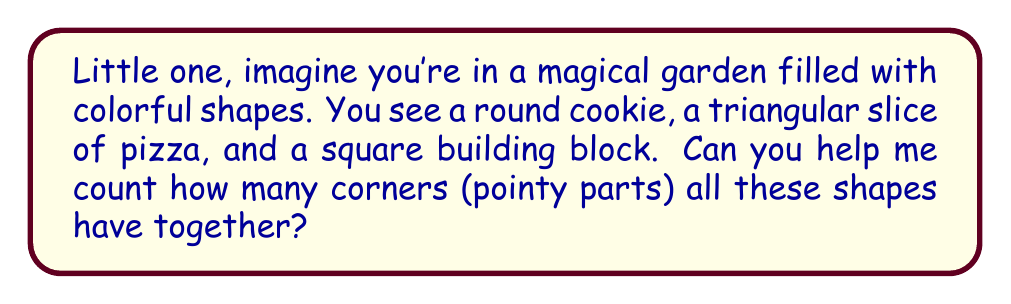Give your solution to this math problem. Let's count the corners for each shape together:

1. The round cookie is a circle. Circles are smooth and round all the way around, so they have no corners.
   Number of corners for the circle: 0

2. The triangular slice of pizza is a triangle. Triangles have three straight sides that meet at three points.
   Number of corners for the triangle: 3

3. The square building block is a square. Squares have four equal sides and four corners where these sides meet.
   Number of corners for the square: 4

Now, let's add up all the corners:
$$ \text{Total corners} = \text{Circle corners} + \text{Triangle corners} + \text{Square corners} $$
$$ \text{Total corners} = 0 + 3 + 4 = 7 $$

So, when we count all the corners from these three shapes, we get 7 corners in total.
Answer: 7 corners 